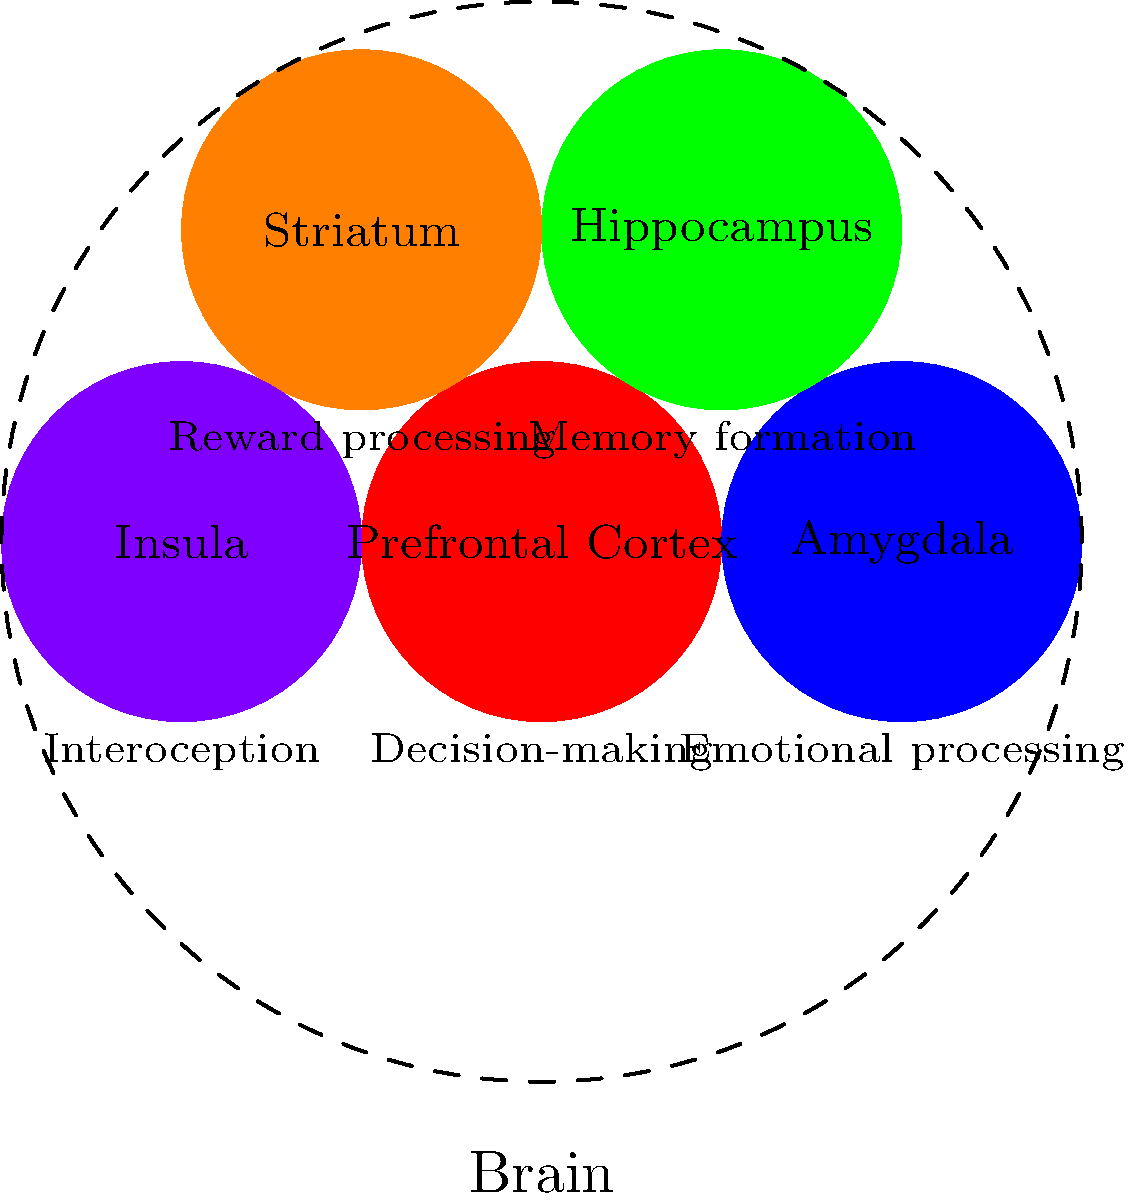Based on the brain topology diagram, which region is most likely associated with impulsive criminal behavior and poor decision-making in individuals with a history of criminal activity? To answer this question, we need to analyze the different brain regions and their associated functions as shown in the diagram:

1. Prefrontal Cortex: Associated with decision-making
2. Amygdala: Associated with emotional processing
3. Hippocampus: Associated with memory formation
4. Striatum: Associated with reward processing
5. Insula: Associated with interoception (internal bodily sensations)

Step 1: Identify the key characteristics of impulsive criminal behavior and poor decision-making.
- Impulsivity involves acting without considering consequences.
- Poor decision-making suggests an inability to weigh options and choose appropriate actions.

Step 2: Match these characteristics with the brain regions and their functions.
- The Prefrontal Cortex is directly linked to decision-making processes.
- Other regions, while important, are not as directly related to decision-making and impulse control.

Step 3: Consider the role of the Prefrontal Cortex in executive functions.
- The Prefrontal Cortex is crucial for executive functions, including:
  a) Planning
  b) Impulse control
  c) Reasoning
  d) Problem-solving

Step 4: Relate Prefrontal Cortex function to criminal behavior.
- Dysfunction or underdevelopment of the Prefrontal Cortex has been associated with:
  a) Increased risk-taking behavior
  b) Poor judgment
  c) Inability to suppress inappropriate actions

Therefore, based on its role in decision-making and impulse control, the Prefrontal Cortex is most likely associated with impulsive criminal behavior and poor decision-making in individuals with a history of criminal activity.
Answer: Prefrontal Cortex 